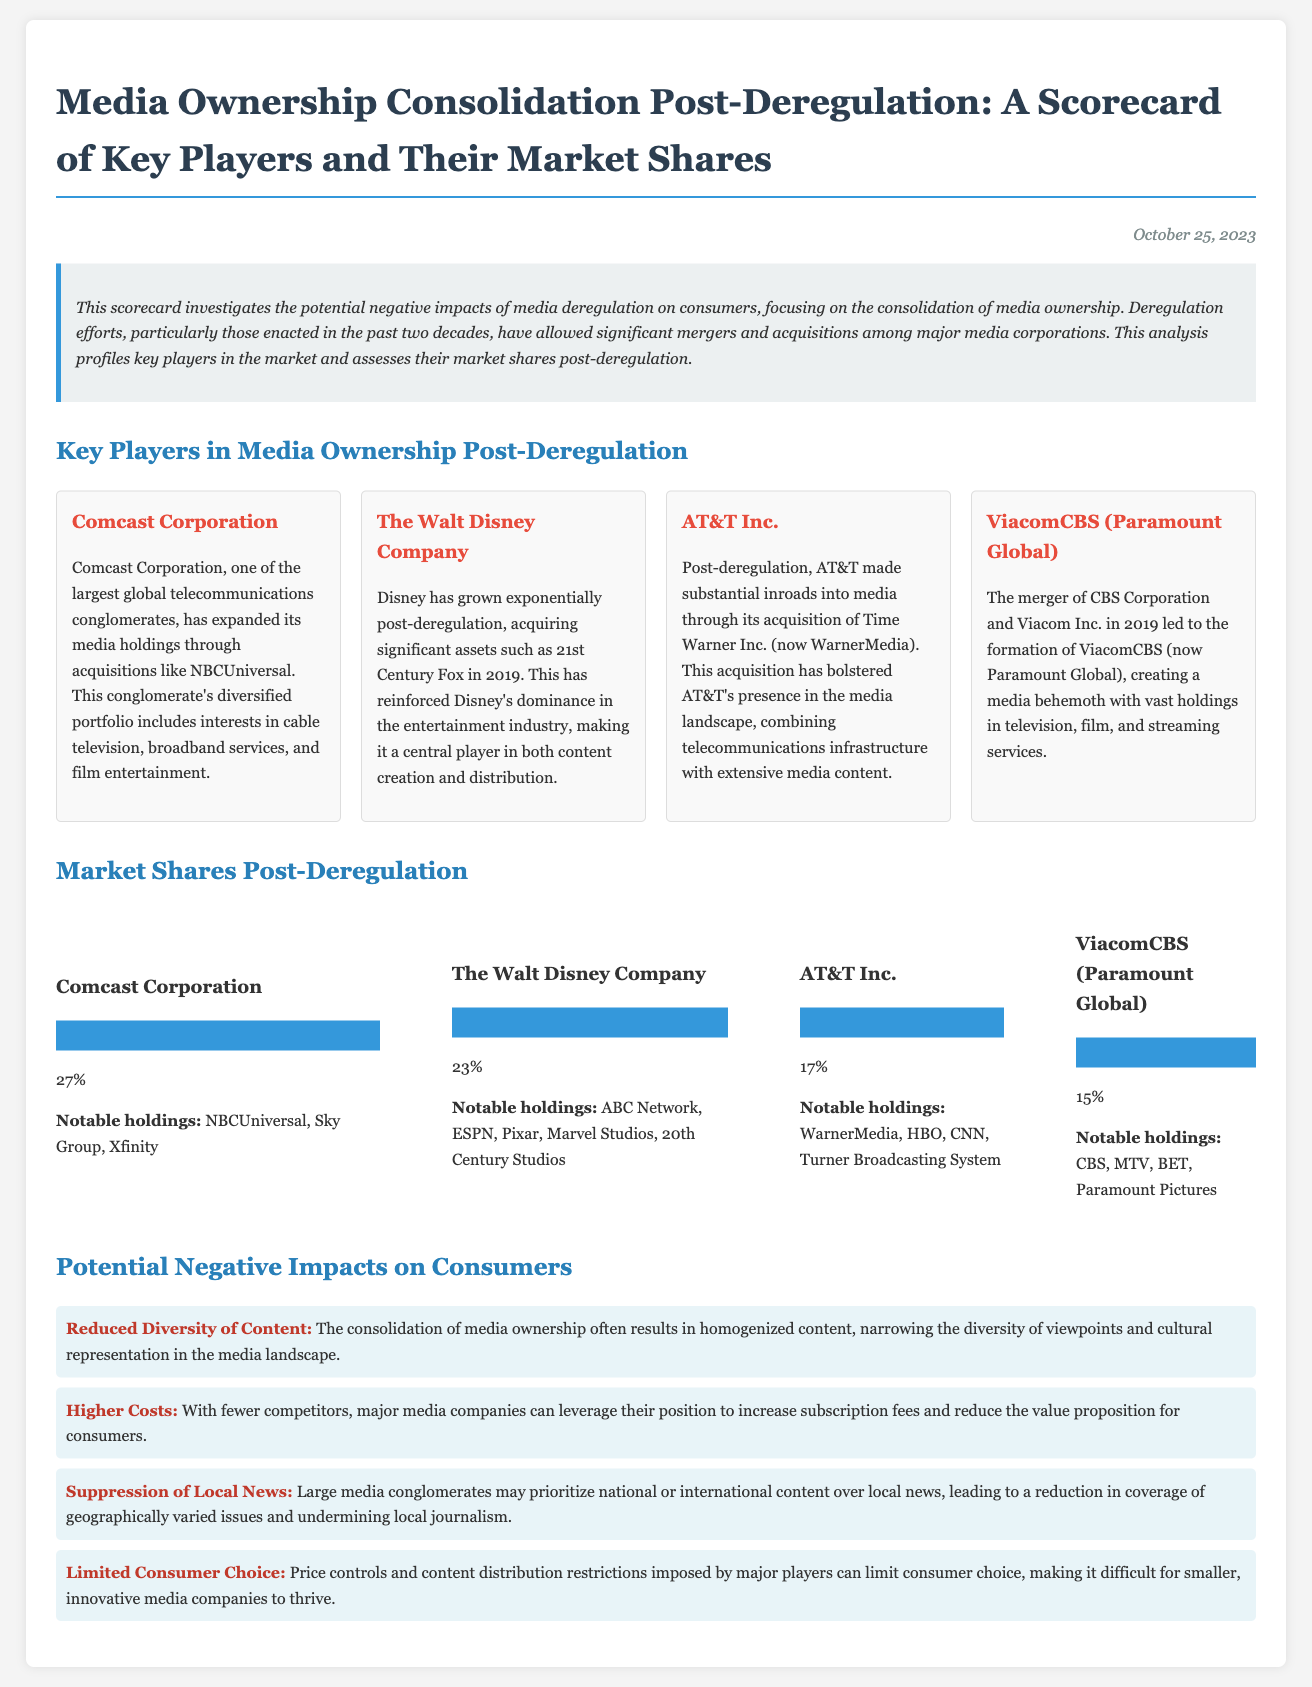What is the market share of Comcast Corporation? The market share for Comcast Corporation is listed in the document as 27%.
Answer: 27% What notable holding does The Walt Disney Company have? The notable holdings for The Walt Disney Company include ABC Network, ESPN, Pixar, Marvel Studios, and 20th Century Studios.
Answer: ABC Network Which company acquired Time Warner Inc.? The document states that AT&T Inc. made the acquisition of Time Warner Inc.
Answer: AT&T Inc What is one potential negative impact of media consolidation on consumers? The scorecard highlights several impacts, one being "Reduced Diversity of Content."
Answer: Reduced Diversity of Content In what year did Disney acquire 21st Century Fox? The document specifies that Disney acquired 21st Century Fox in 2019.
Answer: 2019 Who are the four key players mentioned in the document? The key players listed are Comcast Corporation, The Walt Disney Company, AT&T Inc., and ViacomCBS (Paramount Global).
Answer: Comcast Corporation, The Walt Disney Company, AT&T Inc., ViacomCBS What was the purpose of this scorecard? The scorecard aims to investigate the potential negative impacts of media deregulation on consumers, particularly regarding media ownership consolidation.
Answer: Investigate potential negative impacts What percentage of the market does ViacomCBS hold? The document states that ViacomCBS holds 15% of the market.
Answer: 15% 